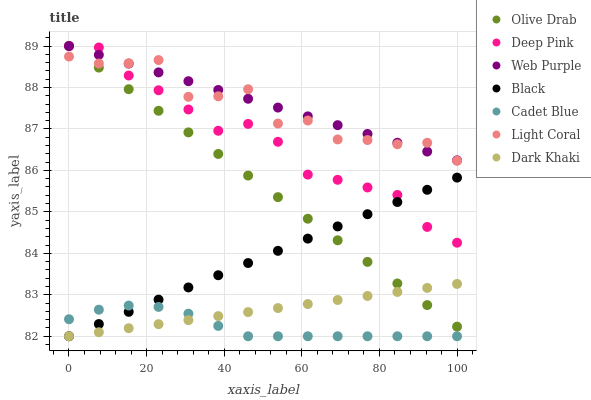Does Cadet Blue have the minimum area under the curve?
Answer yes or no. Yes. Does Web Purple have the maximum area under the curve?
Answer yes or no. Yes. Does Light Coral have the minimum area under the curve?
Answer yes or no. No. Does Light Coral have the maximum area under the curve?
Answer yes or no. No. Is Black the smoothest?
Answer yes or no. Yes. Is Light Coral the roughest?
Answer yes or no. Yes. Is Cadet Blue the smoothest?
Answer yes or no. No. Is Cadet Blue the roughest?
Answer yes or no. No. Does Dark Khaki have the lowest value?
Answer yes or no. Yes. Does Light Coral have the lowest value?
Answer yes or no. No. Does Olive Drab have the highest value?
Answer yes or no. Yes. Does Light Coral have the highest value?
Answer yes or no. No. Is Cadet Blue less than Light Coral?
Answer yes or no. Yes. Is Light Coral greater than Cadet Blue?
Answer yes or no. Yes. Does Web Purple intersect Deep Pink?
Answer yes or no. Yes. Is Web Purple less than Deep Pink?
Answer yes or no. No. Is Web Purple greater than Deep Pink?
Answer yes or no. No. Does Cadet Blue intersect Light Coral?
Answer yes or no. No. 